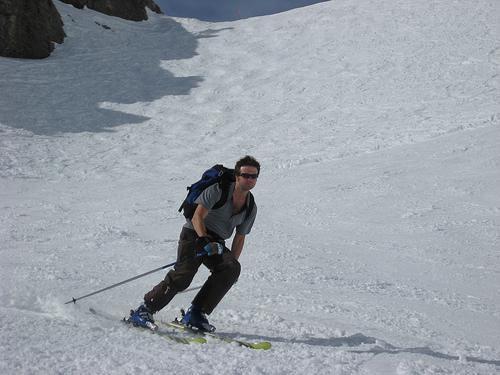How many people are skiing?
Give a very brief answer. 1. 